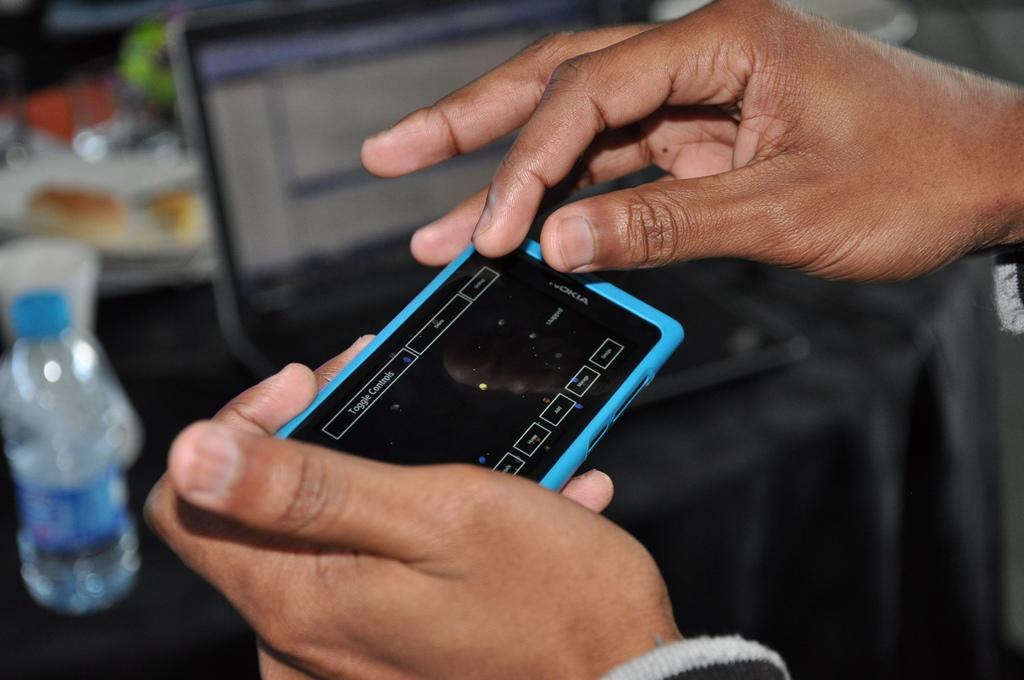<image>
Share a concise interpretation of the image provided. Someone holding a Nokia phone with a black screen 